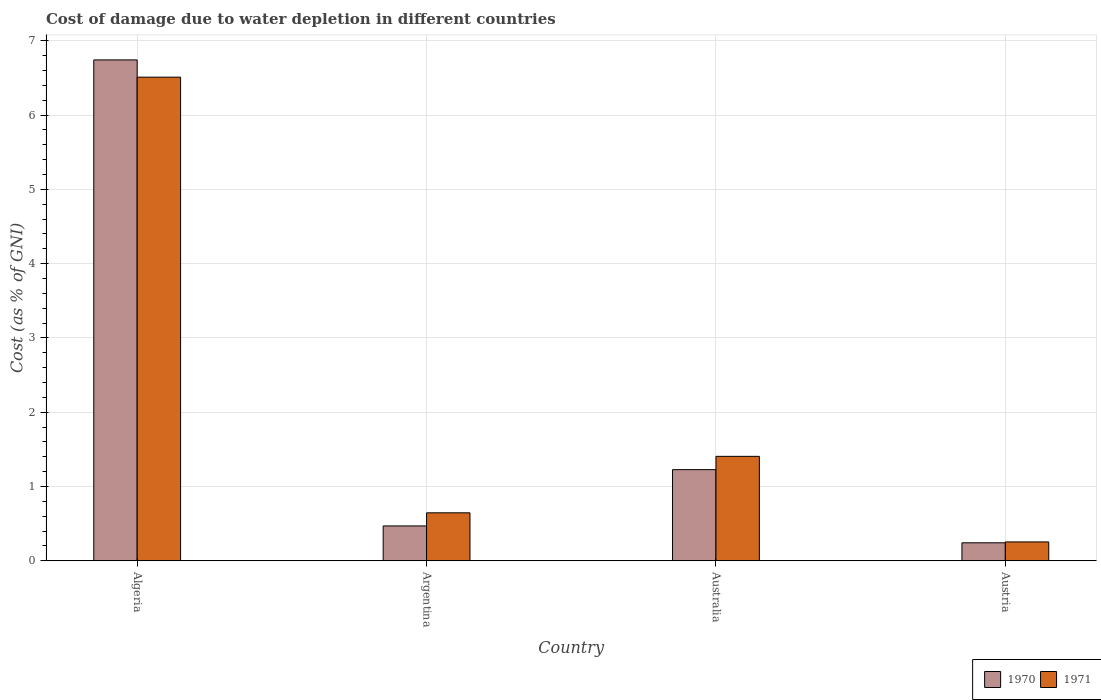How many different coloured bars are there?
Offer a terse response. 2. Are the number of bars per tick equal to the number of legend labels?
Your response must be concise. Yes. What is the cost of damage caused due to water depletion in 1970 in Argentina?
Your response must be concise. 0.47. Across all countries, what is the maximum cost of damage caused due to water depletion in 1970?
Give a very brief answer. 6.74. Across all countries, what is the minimum cost of damage caused due to water depletion in 1970?
Give a very brief answer. 0.24. In which country was the cost of damage caused due to water depletion in 1970 maximum?
Make the answer very short. Algeria. In which country was the cost of damage caused due to water depletion in 1971 minimum?
Keep it short and to the point. Austria. What is the total cost of damage caused due to water depletion in 1971 in the graph?
Give a very brief answer. 8.81. What is the difference between the cost of damage caused due to water depletion in 1970 in Algeria and that in Australia?
Offer a terse response. 5.52. What is the difference between the cost of damage caused due to water depletion in 1971 in Australia and the cost of damage caused due to water depletion in 1970 in Argentina?
Offer a very short reply. 0.94. What is the average cost of damage caused due to water depletion in 1970 per country?
Offer a terse response. 2.17. What is the difference between the cost of damage caused due to water depletion of/in 1971 and cost of damage caused due to water depletion of/in 1970 in Argentina?
Offer a terse response. 0.18. In how many countries, is the cost of damage caused due to water depletion in 1970 greater than 4 %?
Offer a very short reply. 1. What is the ratio of the cost of damage caused due to water depletion in 1971 in Algeria to that in Austria?
Provide a succinct answer. 25.65. Is the cost of damage caused due to water depletion in 1970 in Argentina less than that in Australia?
Ensure brevity in your answer.  Yes. What is the difference between the highest and the second highest cost of damage caused due to water depletion in 1971?
Your answer should be very brief. -0.76. What is the difference between the highest and the lowest cost of damage caused due to water depletion in 1970?
Make the answer very short. 6.5. What does the 1st bar from the left in Algeria represents?
Provide a succinct answer. 1970. What does the 2nd bar from the right in Argentina represents?
Your answer should be compact. 1970. Are all the bars in the graph horizontal?
Keep it short and to the point. No. How many countries are there in the graph?
Your response must be concise. 4. What is the difference between two consecutive major ticks on the Y-axis?
Your answer should be very brief. 1. Does the graph contain any zero values?
Your answer should be very brief. No. Does the graph contain grids?
Offer a very short reply. Yes. How many legend labels are there?
Provide a succinct answer. 2. How are the legend labels stacked?
Provide a succinct answer. Horizontal. What is the title of the graph?
Your answer should be compact. Cost of damage due to water depletion in different countries. What is the label or title of the Y-axis?
Provide a short and direct response. Cost (as % of GNI). What is the Cost (as % of GNI) of 1970 in Algeria?
Provide a short and direct response. 6.74. What is the Cost (as % of GNI) of 1971 in Algeria?
Provide a succinct answer. 6.51. What is the Cost (as % of GNI) of 1970 in Argentina?
Your answer should be compact. 0.47. What is the Cost (as % of GNI) of 1971 in Argentina?
Keep it short and to the point. 0.65. What is the Cost (as % of GNI) in 1970 in Australia?
Make the answer very short. 1.23. What is the Cost (as % of GNI) of 1971 in Australia?
Offer a very short reply. 1.41. What is the Cost (as % of GNI) in 1970 in Austria?
Make the answer very short. 0.24. What is the Cost (as % of GNI) of 1971 in Austria?
Provide a succinct answer. 0.25. Across all countries, what is the maximum Cost (as % of GNI) in 1970?
Offer a very short reply. 6.74. Across all countries, what is the maximum Cost (as % of GNI) of 1971?
Your answer should be compact. 6.51. Across all countries, what is the minimum Cost (as % of GNI) of 1970?
Your answer should be very brief. 0.24. Across all countries, what is the minimum Cost (as % of GNI) in 1971?
Your response must be concise. 0.25. What is the total Cost (as % of GNI) in 1970 in the graph?
Offer a terse response. 8.68. What is the total Cost (as % of GNI) of 1971 in the graph?
Your response must be concise. 8.81. What is the difference between the Cost (as % of GNI) of 1970 in Algeria and that in Argentina?
Keep it short and to the point. 6.27. What is the difference between the Cost (as % of GNI) of 1971 in Algeria and that in Argentina?
Your answer should be compact. 5.86. What is the difference between the Cost (as % of GNI) of 1970 in Algeria and that in Australia?
Keep it short and to the point. 5.52. What is the difference between the Cost (as % of GNI) in 1971 in Algeria and that in Australia?
Give a very brief answer. 5.1. What is the difference between the Cost (as % of GNI) of 1970 in Algeria and that in Austria?
Your response must be concise. 6.5. What is the difference between the Cost (as % of GNI) of 1971 in Algeria and that in Austria?
Ensure brevity in your answer.  6.26. What is the difference between the Cost (as % of GNI) of 1970 in Argentina and that in Australia?
Ensure brevity in your answer.  -0.76. What is the difference between the Cost (as % of GNI) in 1971 in Argentina and that in Australia?
Ensure brevity in your answer.  -0.76. What is the difference between the Cost (as % of GNI) of 1970 in Argentina and that in Austria?
Offer a terse response. 0.23. What is the difference between the Cost (as % of GNI) of 1971 in Argentina and that in Austria?
Keep it short and to the point. 0.39. What is the difference between the Cost (as % of GNI) in 1970 in Australia and that in Austria?
Provide a short and direct response. 0.98. What is the difference between the Cost (as % of GNI) in 1971 in Australia and that in Austria?
Your answer should be compact. 1.15. What is the difference between the Cost (as % of GNI) in 1970 in Algeria and the Cost (as % of GNI) in 1971 in Argentina?
Your answer should be compact. 6.1. What is the difference between the Cost (as % of GNI) of 1970 in Algeria and the Cost (as % of GNI) of 1971 in Australia?
Make the answer very short. 5.34. What is the difference between the Cost (as % of GNI) of 1970 in Algeria and the Cost (as % of GNI) of 1971 in Austria?
Ensure brevity in your answer.  6.49. What is the difference between the Cost (as % of GNI) in 1970 in Argentina and the Cost (as % of GNI) in 1971 in Australia?
Offer a terse response. -0.94. What is the difference between the Cost (as % of GNI) of 1970 in Argentina and the Cost (as % of GNI) of 1971 in Austria?
Offer a very short reply. 0.22. What is the difference between the Cost (as % of GNI) of 1970 in Australia and the Cost (as % of GNI) of 1971 in Austria?
Ensure brevity in your answer.  0.97. What is the average Cost (as % of GNI) in 1970 per country?
Your response must be concise. 2.17. What is the average Cost (as % of GNI) in 1971 per country?
Keep it short and to the point. 2.2. What is the difference between the Cost (as % of GNI) of 1970 and Cost (as % of GNI) of 1971 in Algeria?
Offer a very short reply. 0.23. What is the difference between the Cost (as % of GNI) of 1970 and Cost (as % of GNI) of 1971 in Argentina?
Give a very brief answer. -0.18. What is the difference between the Cost (as % of GNI) in 1970 and Cost (as % of GNI) in 1971 in Australia?
Your answer should be compact. -0.18. What is the difference between the Cost (as % of GNI) of 1970 and Cost (as % of GNI) of 1971 in Austria?
Ensure brevity in your answer.  -0.01. What is the ratio of the Cost (as % of GNI) in 1970 in Algeria to that in Argentina?
Offer a very short reply. 14.38. What is the ratio of the Cost (as % of GNI) in 1971 in Algeria to that in Argentina?
Give a very brief answer. 10.08. What is the ratio of the Cost (as % of GNI) of 1970 in Algeria to that in Australia?
Provide a succinct answer. 5.5. What is the ratio of the Cost (as % of GNI) of 1971 in Algeria to that in Australia?
Ensure brevity in your answer.  4.63. What is the ratio of the Cost (as % of GNI) of 1970 in Algeria to that in Austria?
Your answer should be very brief. 27.86. What is the ratio of the Cost (as % of GNI) of 1971 in Algeria to that in Austria?
Provide a succinct answer. 25.65. What is the ratio of the Cost (as % of GNI) of 1970 in Argentina to that in Australia?
Make the answer very short. 0.38. What is the ratio of the Cost (as % of GNI) of 1971 in Argentina to that in Australia?
Provide a short and direct response. 0.46. What is the ratio of the Cost (as % of GNI) in 1970 in Argentina to that in Austria?
Offer a very short reply. 1.94. What is the ratio of the Cost (as % of GNI) in 1971 in Argentina to that in Austria?
Your answer should be very brief. 2.54. What is the ratio of the Cost (as % of GNI) in 1970 in Australia to that in Austria?
Ensure brevity in your answer.  5.07. What is the ratio of the Cost (as % of GNI) of 1971 in Australia to that in Austria?
Keep it short and to the point. 5.54. What is the difference between the highest and the second highest Cost (as % of GNI) of 1970?
Your answer should be compact. 5.52. What is the difference between the highest and the second highest Cost (as % of GNI) in 1971?
Give a very brief answer. 5.1. What is the difference between the highest and the lowest Cost (as % of GNI) in 1970?
Provide a succinct answer. 6.5. What is the difference between the highest and the lowest Cost (as % of GNI) in 1971?
Ensure brevity in your answer.  6.26. 